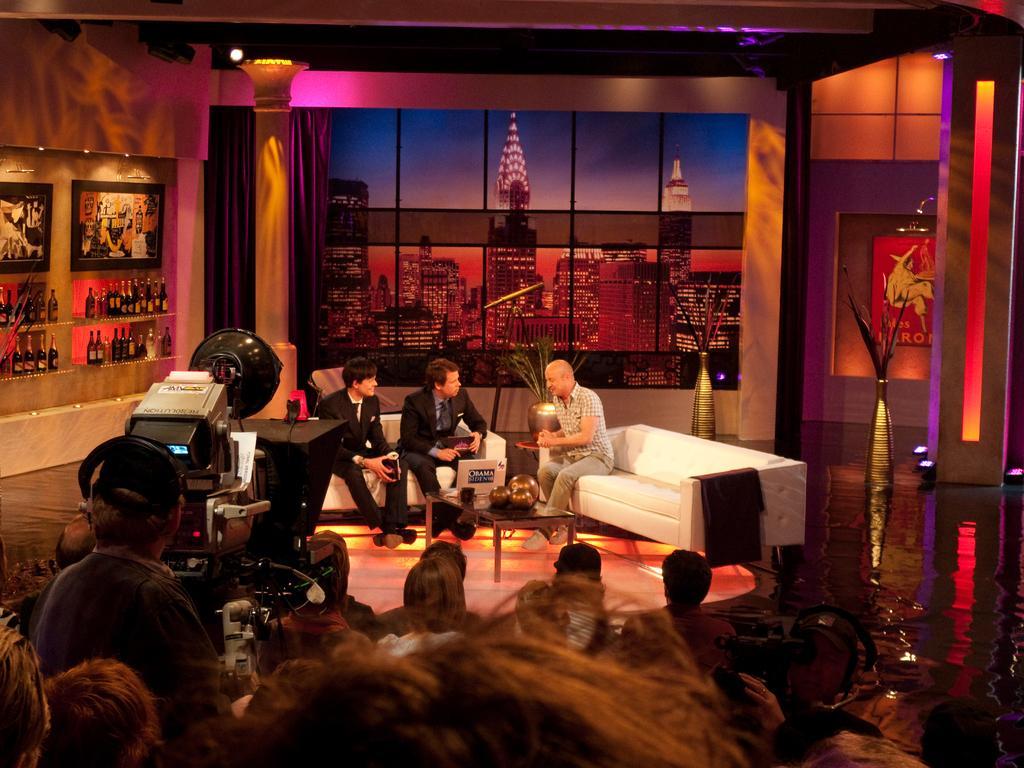In one or two sentences, can you explain what this image depicts? In this image people are sitting on chairs, on the left there is a camera, in the background there are two sofas three persons sitting on sofas, in front of them there is a table, on that table there are objects and there are walls. 